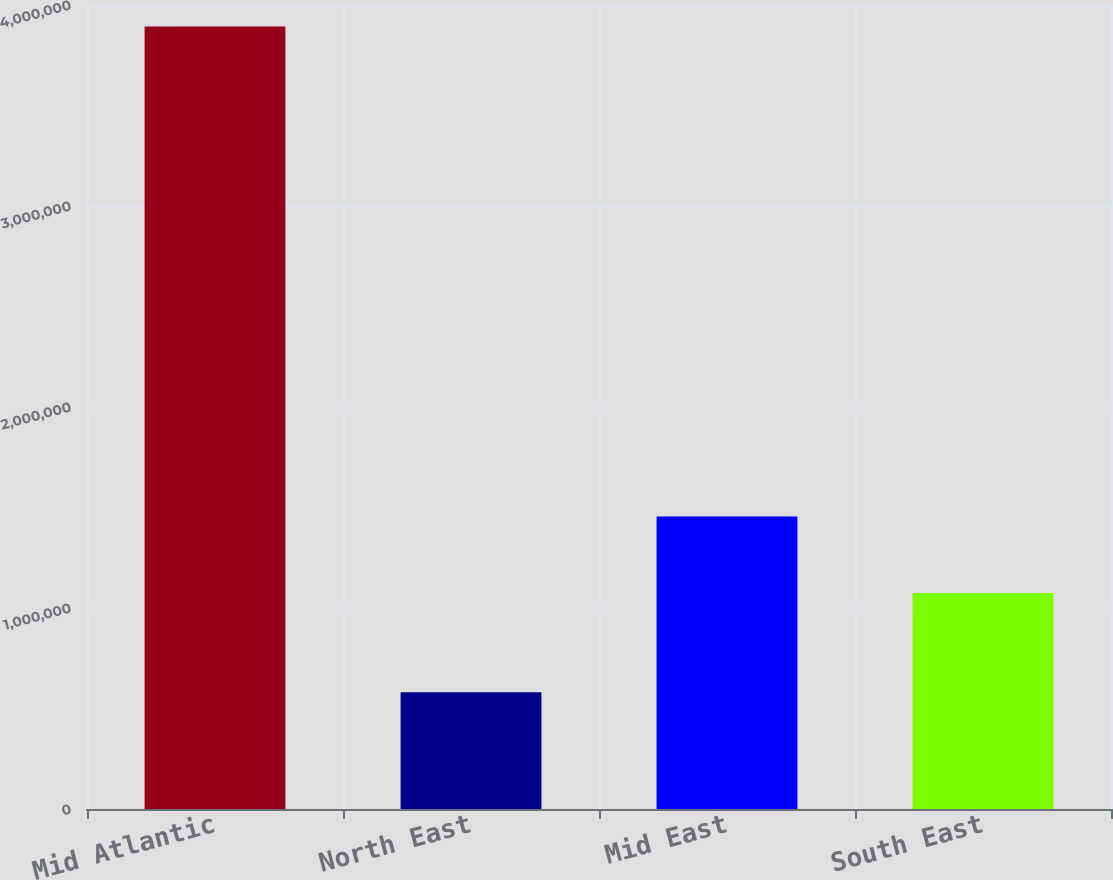<chart> <loc_0><loc_0><loc_500><loc_500><bar_chart><fcel>Mid Atlantic<fcel>North East<fcel>Mid East<fcel>South East<nl><fcel>3.89336e+06<fcel>580726<fcel>1.45583e+06<fcel>1.07439e+06<nl></chart> 